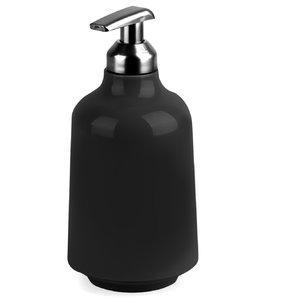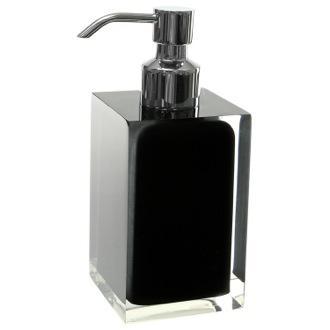The first image is the image on the left, the second image is the image on the right. Examine the images to the left and right. Is the description "The pump on one bottle has a spout that emerges horizontally, but then angles downward slightly, while the pump of the other bottle is horizontal with no angle." accurate? Answer yes or no. Yes. The first image is the image on the left, the second image is the image on the right. For the images displayed, is the sentence "The right image contains a black dispenser with a chrome top." factually correct? Answer yes or no. Yes. 